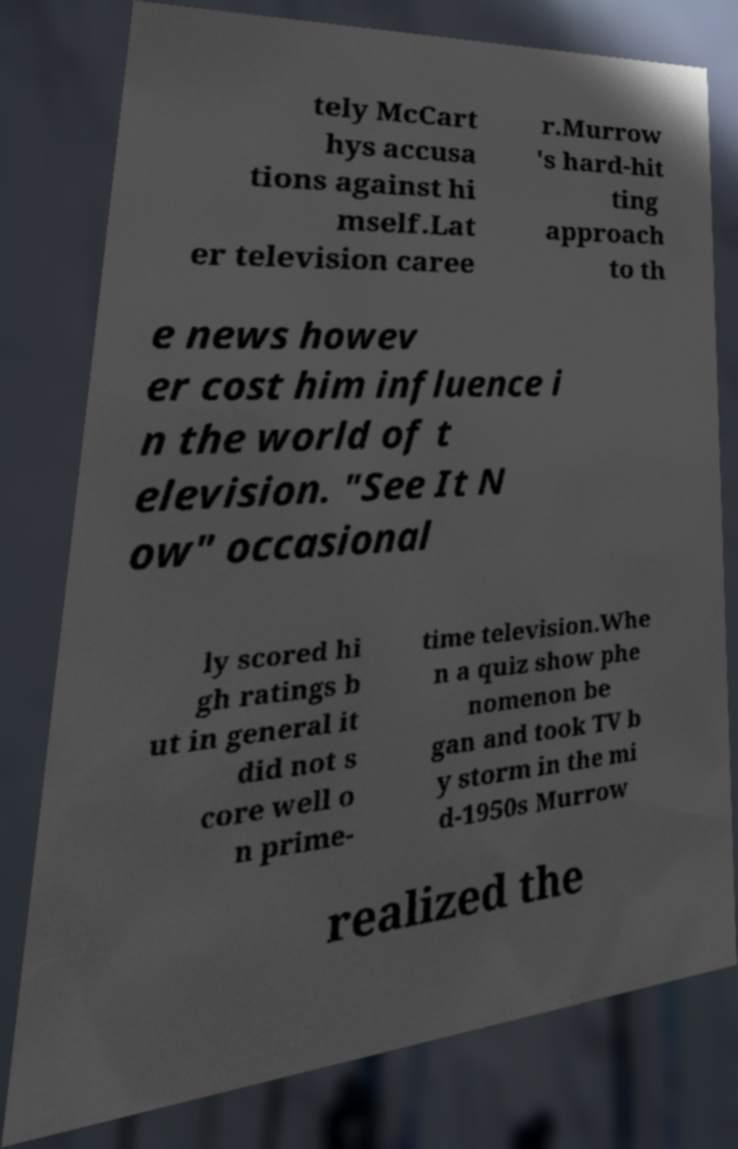There's text embedded in this image that I need extracted. Can you transcribe it verbatim? tely McCart hys accusa tions against hi mself.Lat er television caree r.Murrow 's hard-hit ting approach to th e news howev er cost him influence i n the world of t elevision. "See It N ow" occasional ly scored hi gh ratings b ut in general it did not s core well o n prime- time television.Whe n a quiz show phe nomenon be gan and took TV b y storm in the mi d-1950s Murrow realized the 